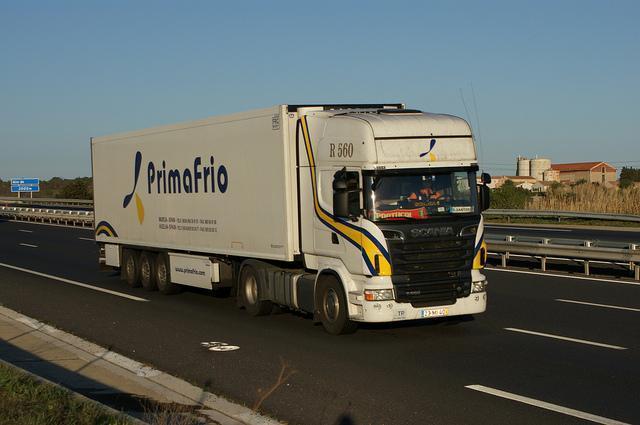How many red braces can be seen?
Give a very brief answer. 0. How many wheels are visible?
Give a very brief answer. 5. How many forks are in the picture?
Give a very brief answer. 0. 